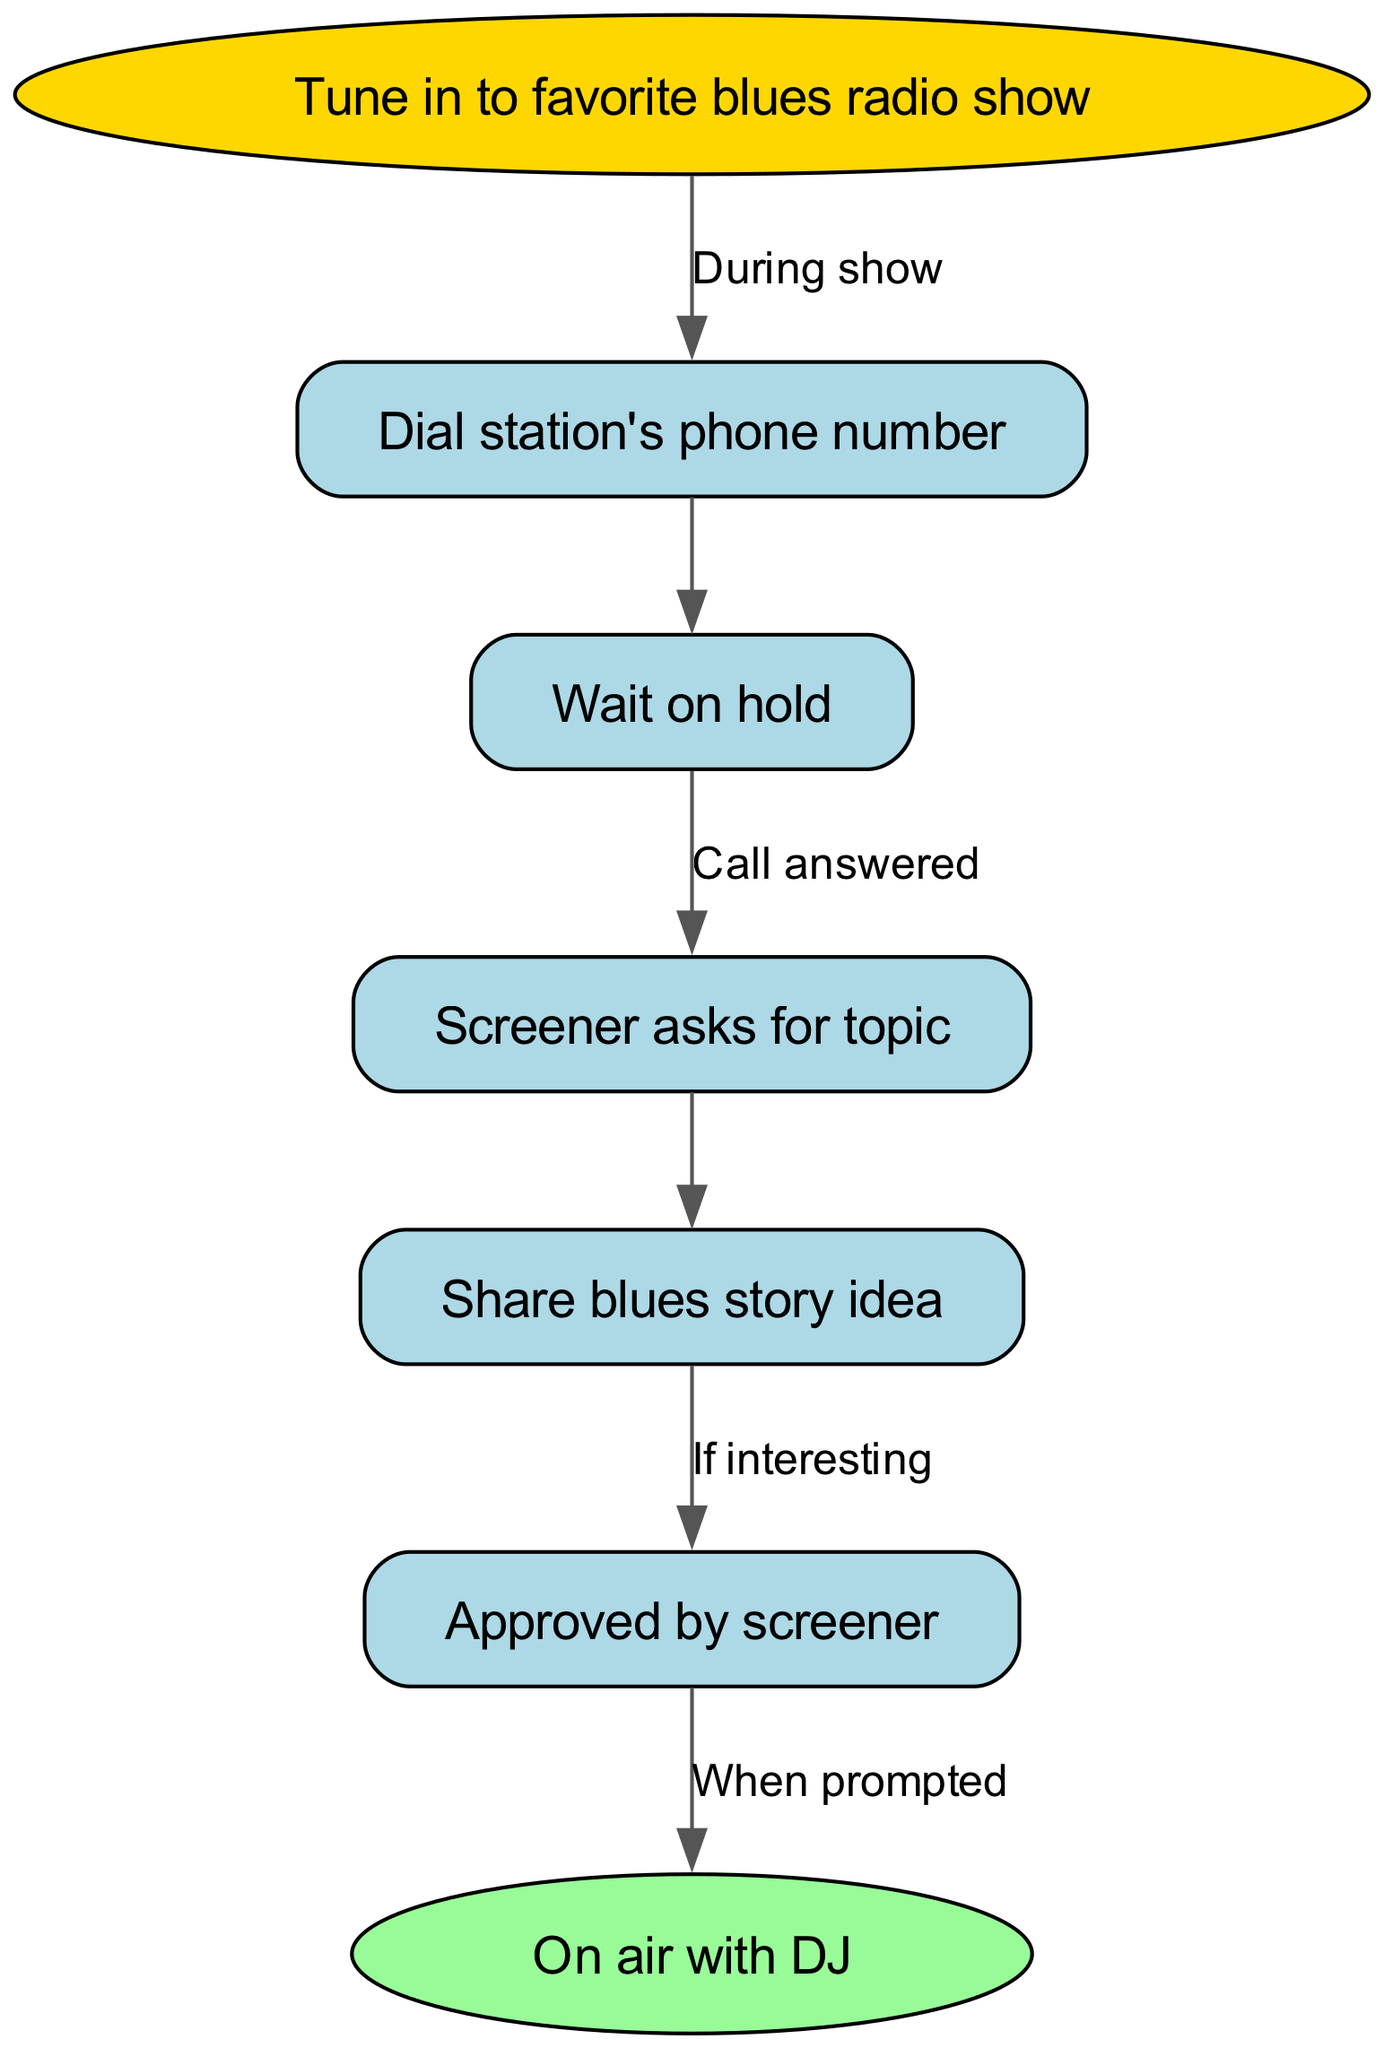What's the first step in the process? The first node in the diagram is "Tune in to favorite blues radio show," which indicates that this is the starting point for calling into the radio show.
Answer: Tune in to favorite blues radio show How many nodes are in the diagram? By counting the items listed in the "nodes" section, there are a total of 7 nodes representing different steps in the process.
Answer: 7 What happens after dialing the station's phone number? After "Dial station's phone number," the next step in the process as indicated by the flow of the edges is "Wait on hold."
Answer: Wait on hold What does the screener ask for? The node "Screener asks for topic" defines what the screener will inquire about before deciding if the person can go on air, specifically asking for the caller's topic.
Answer: Topic What occurs if the story idea is interesting? According to the diagram, if the story idea shared with the screener is interesting, this leads to the approval process, represented as "Approved by screener."
Answer: Approved by screener What is the last step before going on air with the DJ? The edge leading to the last node indicates that the transition from "Approved by screener" occurs "When prompted," leading to the final step of being on air with the DJ.
Answer: When prompted What is the relationship between "Wait on hold" and "Screener asks for topic"? The edge connecting "Wait on hold" to "Screener asks for topic" indicates that the latter occurs after a call is answered, thus establishing a sequential relationship.
Answer: Call answered How many edges connect the nodes in this diagram? The number of edges is determined by counting the items listed in the "edges" section, resulting in a total of 6 connections between nodes that describe the flow of the process.
Answer: 6 What does the last node in the diagram represent? The final node, labeled "On air with DJ," represents the conclusion of the process where the caller is live on the program, sharing their story.
Answer: On air with DJ 